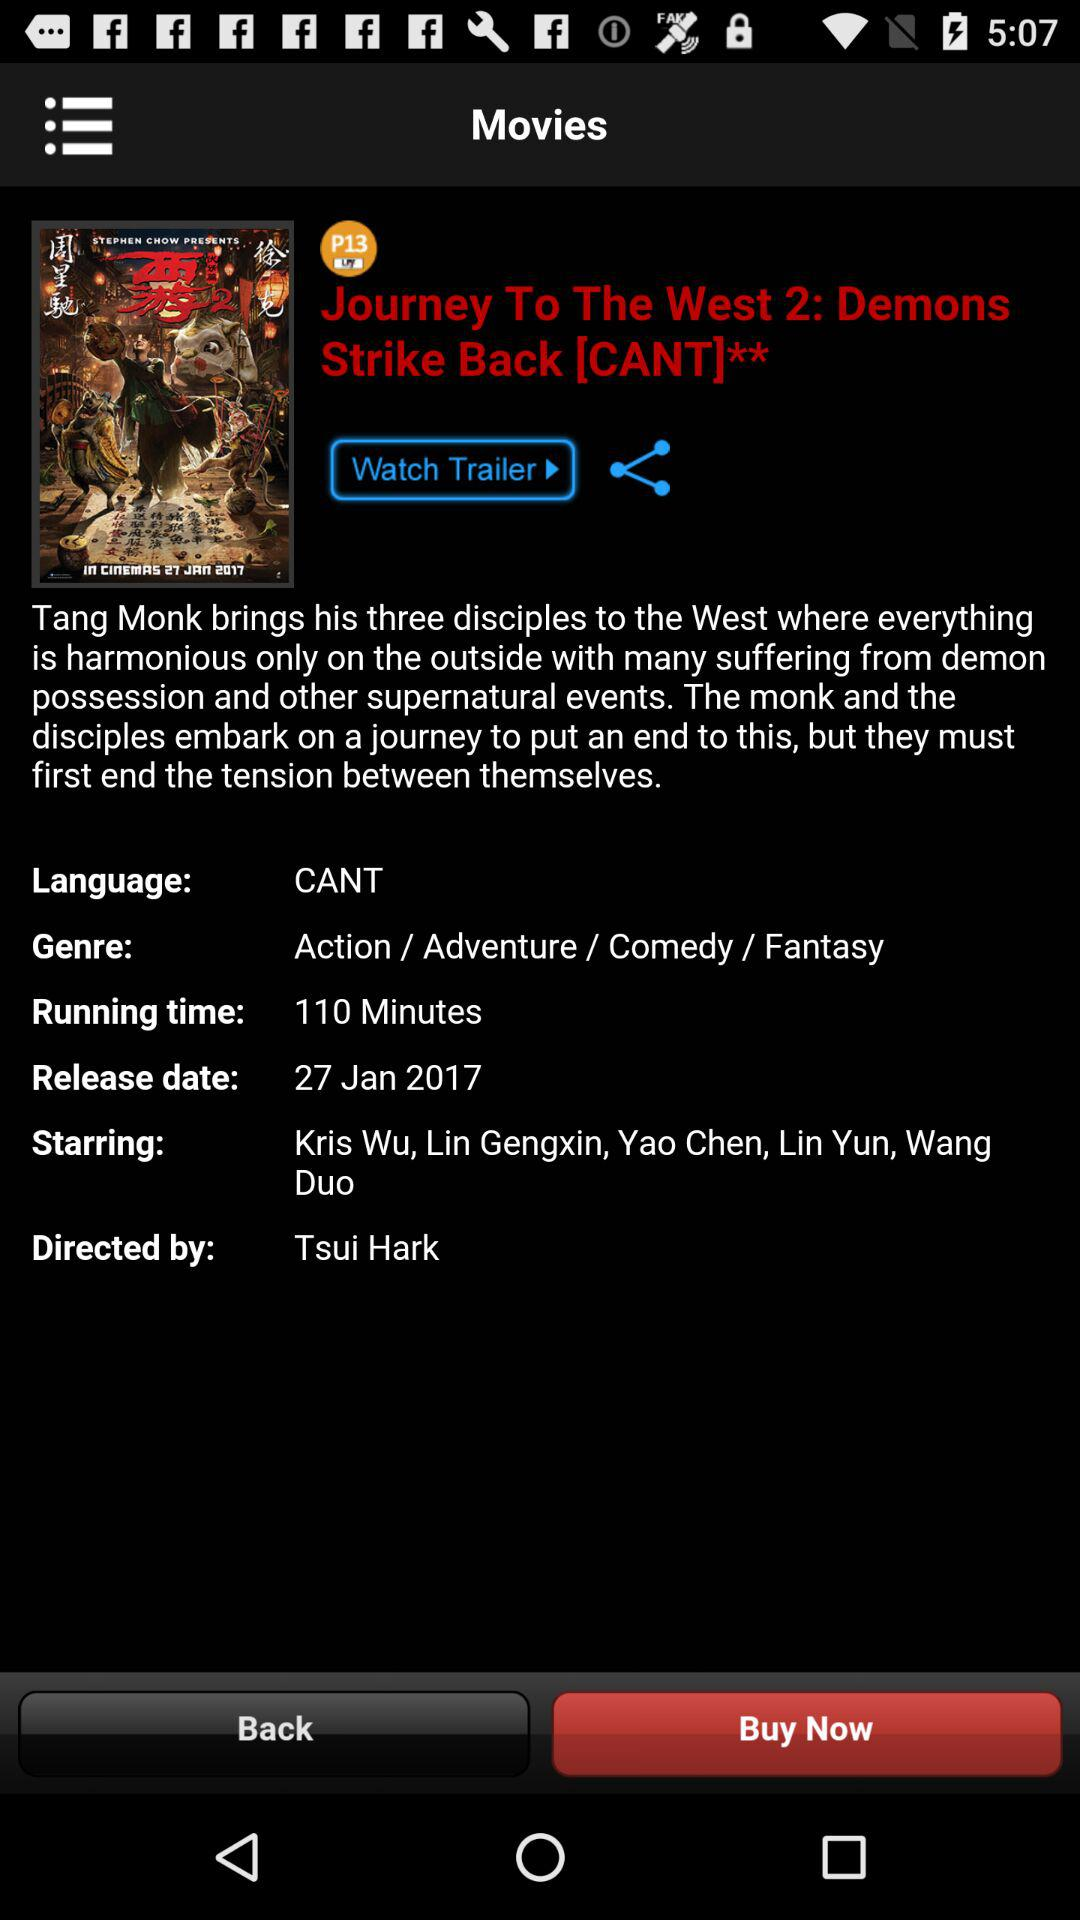Who's the starcast in the movie? The starcasts in the movie are Kris Wu, Lin Gengxin, Yao Chen, Lin Yun and Wang Duo. 